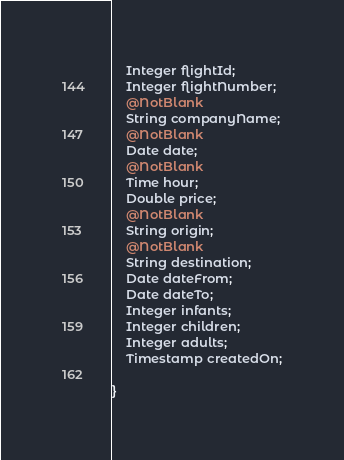<code> <loc_0><loc_0><loc_500><loc_500><_Java_>    Integer flightId;
    Integer flightNumber;
    @NotBlank
    String companyName;
    @NotBlank
    Date date;
    @NotBlank
    Time hour;
    Double price;
    @NotBlank
    String origin;
    @NotBlank
    String destination;
    Date dateFrom;
    Date dateTo;
    Integer infants;
    Integer children;
    Integer adults;
    Timestamp createdOn;

}
</code> 